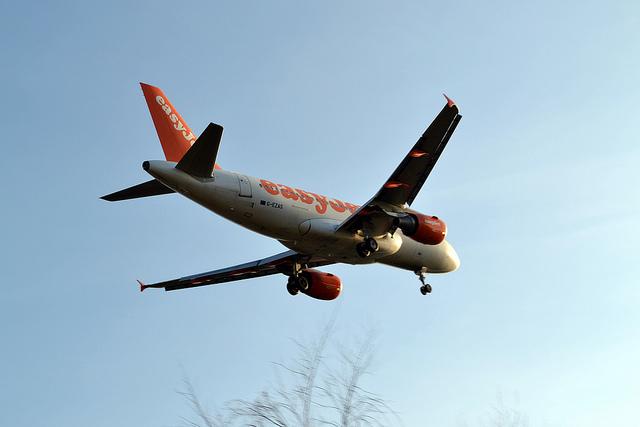What airline is this?
Keep it brief. Easyjet. What is coming from the plane's engine?
Short answer required. Nothing. What does the plane say?
Write a very short answer. Easy. Why are the wheels down?
Be succinct. Landing. Is there a street light?
Concise answer only. No. 